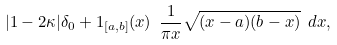<formula> <loc_0><loc_0><loc_500><loc_500>| 1 - 2 \kappa | \delta _ { 0 } + 1 _ { [ a , b ] } ( x ) \ \frac { 1 } { \pi x } \sqrt { ( x - a ) ( b - x ) } \ d x ,</formula> 